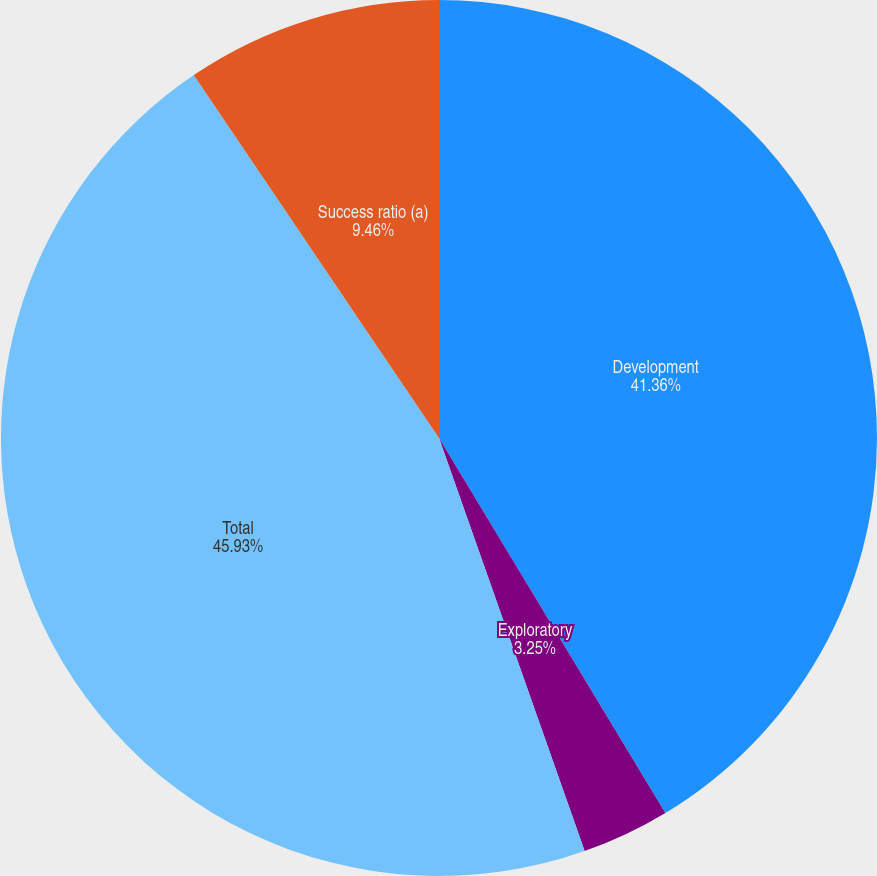Convert chart. <chart><loc_0><loc_0><loc_500><loc_500><pie_chart><fcel>Development<fcel>Exploratory<fcel>Total<fcel>Success ratio (a)<nl><fcel>41.36%<fcel>3.25%<fcel>45.94%<fcel>9.46%<nl></chart> 